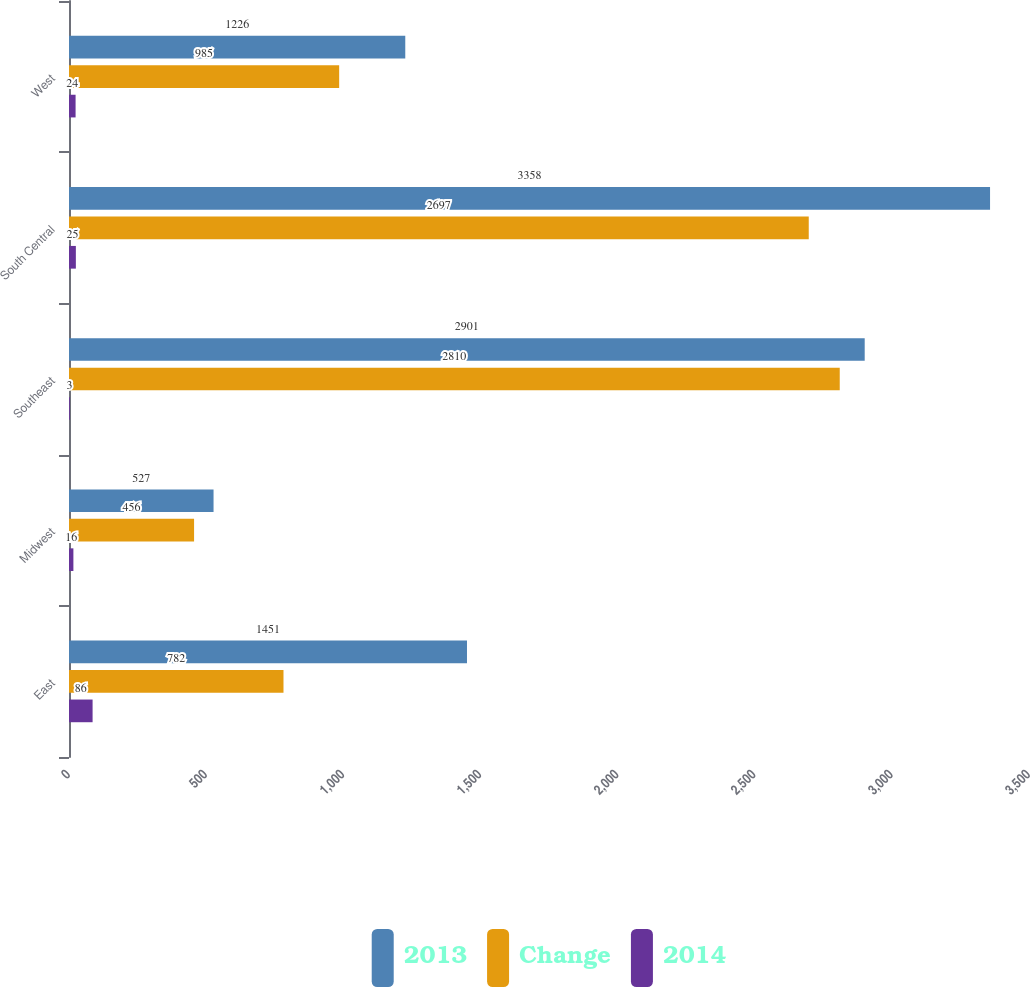<chart> <loc_0><loc_0><loc_500><loc_500><stacked_bar_chart><ecel><fcel>East<fcel>Midwest<fcel>Southeast<fcel>South Central<fcel>West<nl><fcel>2013<fcel>1451<fcel>527<fcel>2901<fcel>3358<fcel>1226<nl><fcel>Change<fcel>782<fcel>456<fcel>2810<fcel>2697<fcel>985<nl><fcel>2014<fcel>86<fcel>16<fcel>3<fcel>25<fcel>24<nl></chart> 